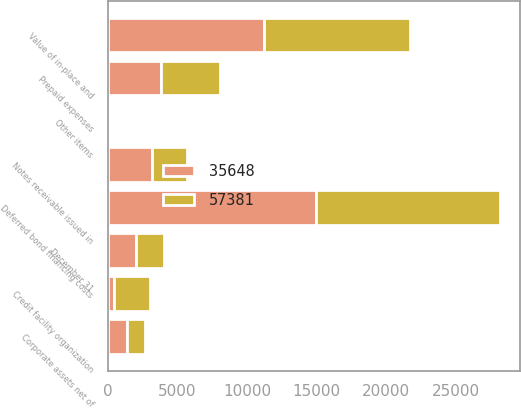<chart> <loc_0><loc_0><loc_500><loc_500><stacked_bar_chart><ecel><fcel>December 31<fcel>Notes receivable issued in<fcel>Deferred bond financing costs<fcel>Value of in-place and<fcel>Prepaid expenses<fcel>Credit facility organization<fcel>Corporate assets net of<fcel>Other items<nl><fcel>57381<fcel>2008<fcel>2552<fcel>13249<fcel>10534<fcel>4244<fcel>2552<fcel>1277<fcel>7<nl><fcel>35648<fcel>2007<fcel>3132<fcel>14940<fcel>11211<fcel>3803<fcel>434<fcel>1356<fcel>13<nl></chart> 